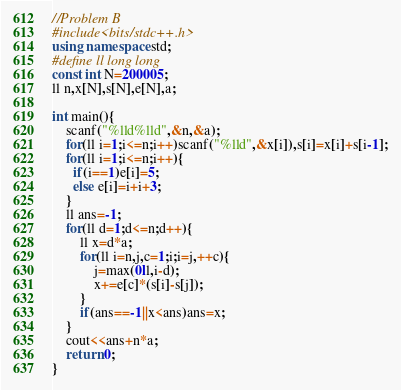<code> <loc_0><loc_0><loc_500><loc_500><_C++_>//Problem B
#include<bits/stdc++.h>
using namespace std;
#define ll long long
const int N=200005;
ll n,x[N],s[N],e[N],a;

int main(){
    scanf("%lld%lld",&n,&a);
    for(ll i=1;i<=n;i++)scanf("%lld",&x[i]),s[i]=x[i]+s[i-1];
    for(ll i=1;i<=n;i++){
      if(i==1)e[i]=5;
      else e[i]=i+i+3;
    }
    ll ans=-1;
    for(ll d=1;d<=n;d++){
        ll x=d*a;
        for(ll i=n,j,c=1;i;i=j,++c){
            j=max(0ll,i-d);
            x+=e[c]*(s[i]-s[j]);
        }
        if(ans==-1||x<ans)ans=x;
    }
    cout<<ans+n*a;
    return 0;
}</code> 